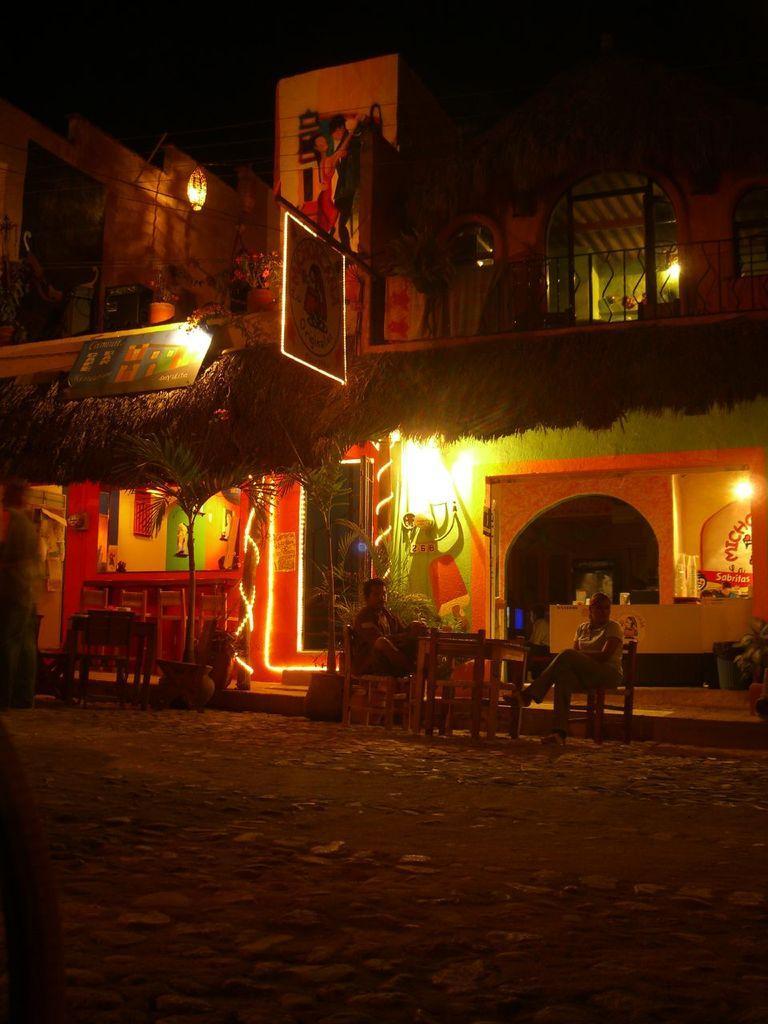Could you give a brief overview of what you see in this image? In this image I see a house which is of lighting and I see few chairs and table over here and there are persons sitting on the chairs. 